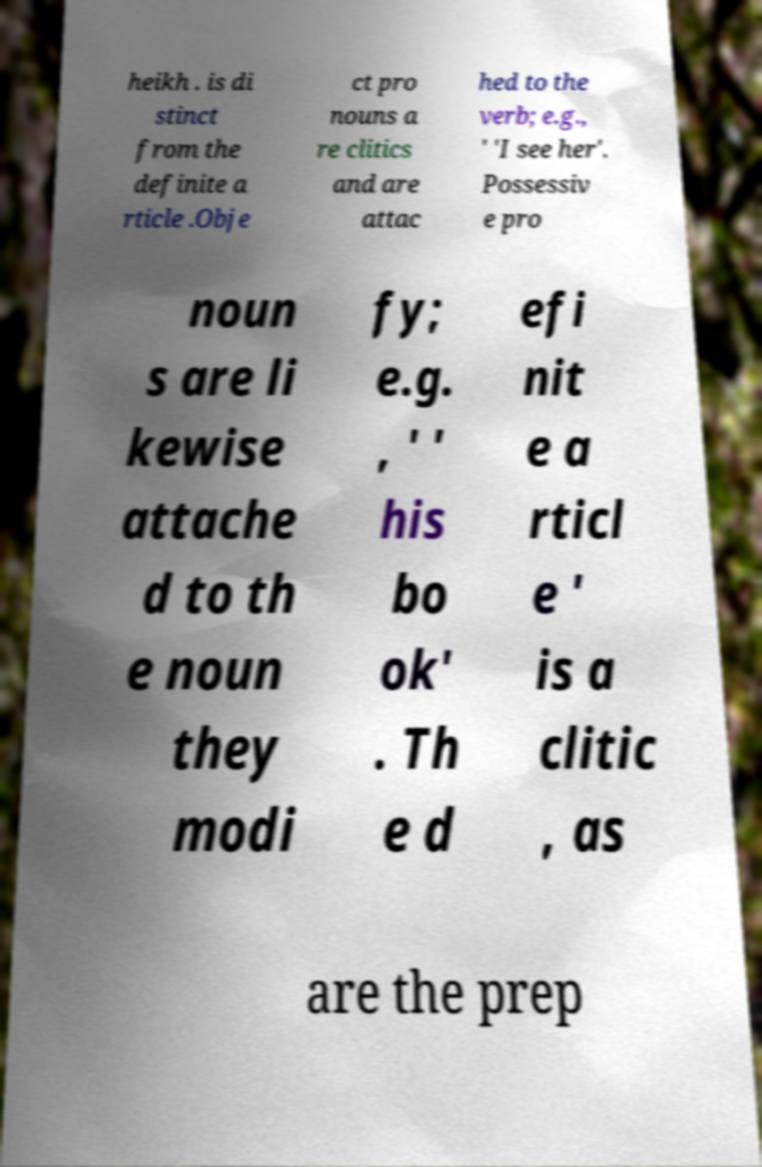What messages or text are displayed in this image? I need them in a readable, typed format. heikh . is di stinct from the definite a rticle .Obje ct pro nouns a re clitics and are attac hed to the verb; e.g., ' 'I see her'. Possessiv e pro noun s are li kewise attache d to th e noun they modi fy; e.g. , ' ' his bo ok' . Th e d efi nit e a rticl e ' is a clitic , as are the prep 